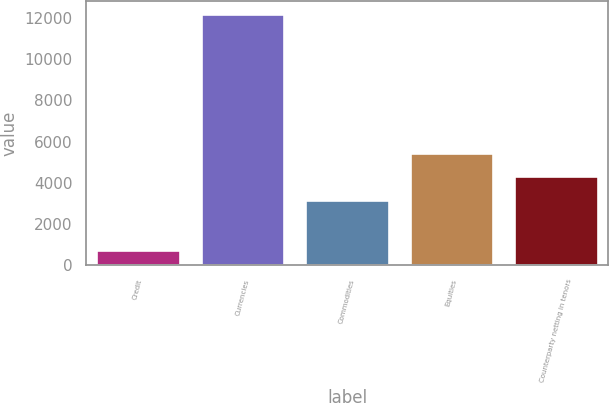Convert chart. <chart><loc_0><loc_0><loc_500><loc_500><bar_chart><fcel>Credit<fcel>Currencies<fcel>Commodities<fcel>Equities<fcel>Counterparty netting in tenors<nl><fcel>760<fcel>12184<fcel>3175<fcel>5459.8<fcel>4317.4<nl></chart> 